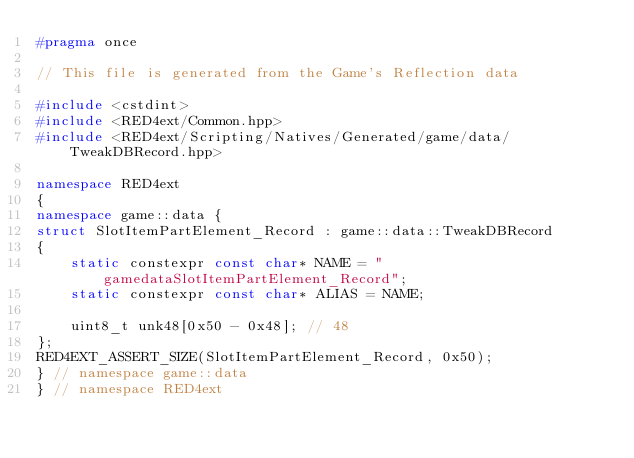<code> <loc_0><loc_0><loc_500><loc_500><_C++_>#pragma once

// This file is generated from the Game's Reflection data

#include <cstdint>
#include <RED4ext/Common.hpp>
#include <RED4ext/Scripting/Natives/Generated/game/data/TweakDBRecord.hpp>

namespace RED4ext
{
namespace game::data { 
struct SlotItemPartElement_Record : game::data::TweakDBRecord
{
    static constexpr const char* NAME = "gamedataSlotItemPartElement_Record";
    static constexpr const char* ALIAS = NAME;

    uint8_t unk48[0x50 - 0x48]; // 48
};
RED4EXT_ASSERT_SIZE(SlotItemPartElement_Record, 0x50);
} // namespace game::data
} // namespace RED4ext
</code> 